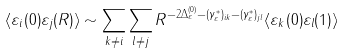<formula> <loc_0><loc_0><loc_500><loc_500>\langle \varepsilon _ { i } ( 0 ) \varepsilon _ { j } ( R ) \rangle \sim \sum _ { k \ne i } \sum _ { l \ne j } R ^ { - 2 \Delta _ { \varepsilon } ^ { ( 0 ) } - ( \gamma ^ { * } _ { \varepsilon } ) _ { i k } - ( \gamma ^ { * } _ { \varepsilon } ) _ { j l } } \langle \varepsilon _ { k } ( 0 ) \varepsilon _ { l } ( 1 ) \rangle</formula> 